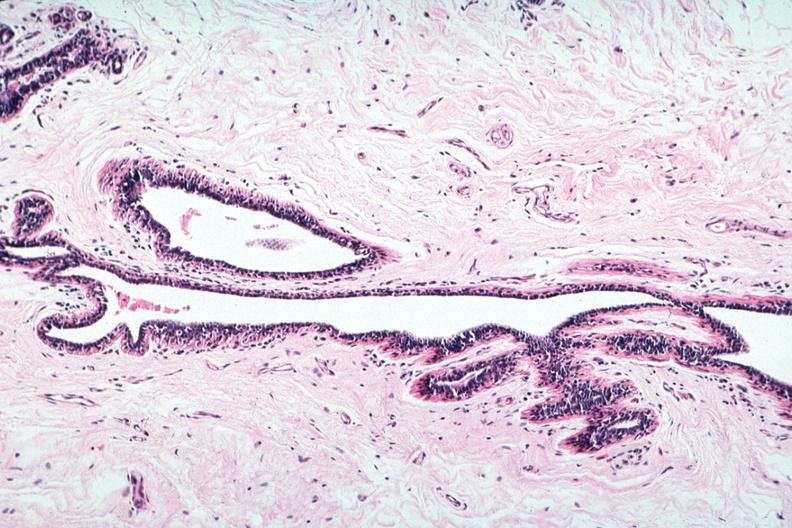what is present?
Answer the question using a single word or phrase. Atrophy 